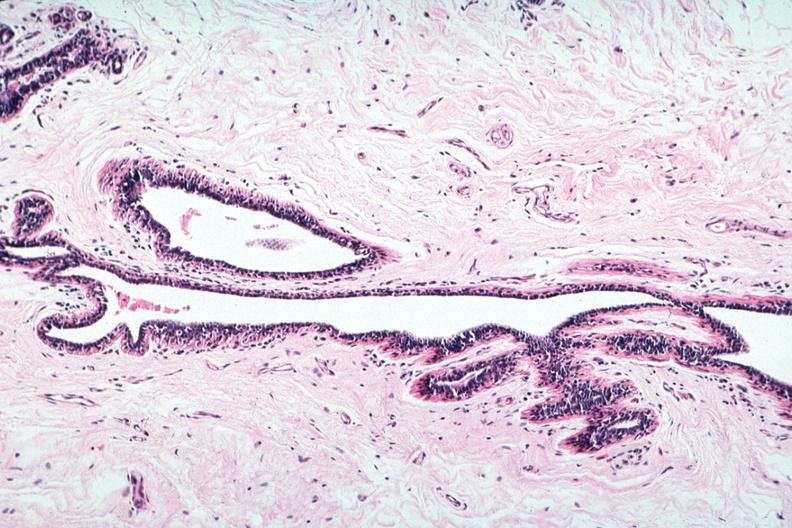what is present?
Answer the question using a single word or phrase. Atrophy 